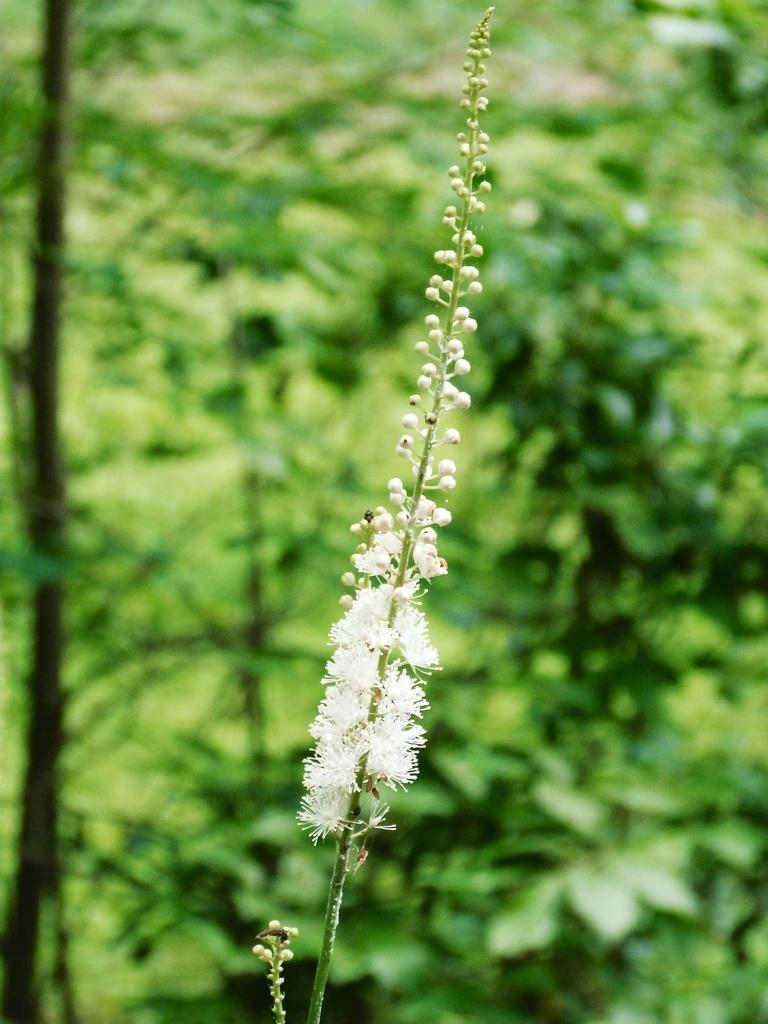What type of flora can be seen in the image? There are flowers in the image. What color are the flowers? The flowers are white. What can be seen in the background of the image? There are plants in the background of the image. What color are the plants? The plants are green. How much money is hidden among the flowers in the image? There is no money present in the image; it only features flowers and plants. What type of balloon can be seen floating above the flowers in the image? There is no balloon present in the image; it only features flowers and plants. 